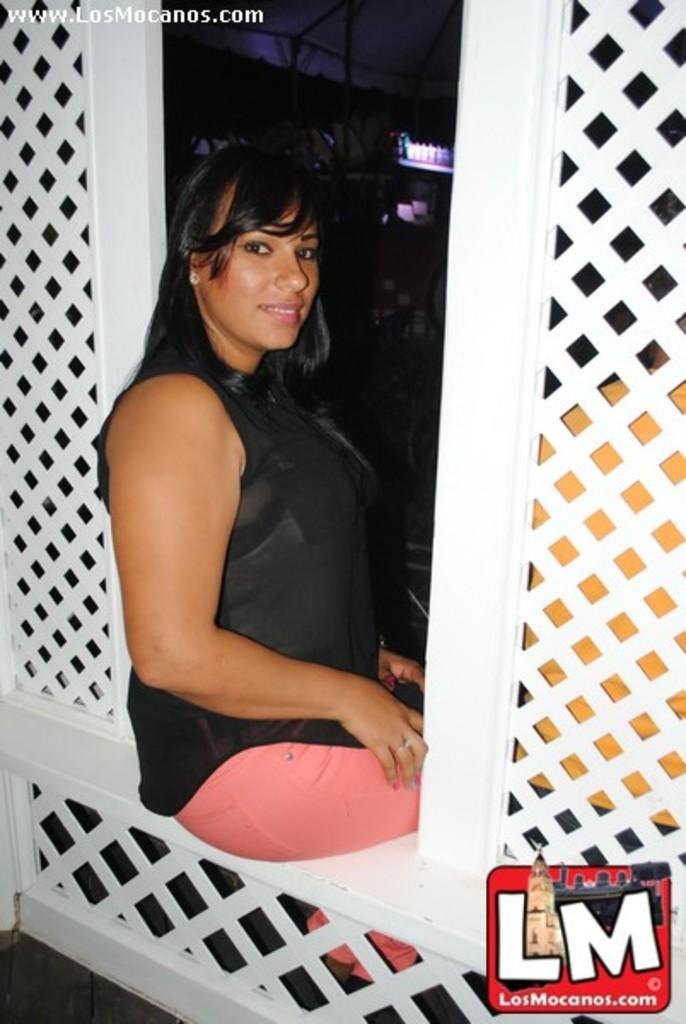What is the woman in the image doing? The woman is sitting on a fence in the image. Can you describe the person sitting behind the fence? There is a person sitting behind the fence on the right side. What can be seen in the background of the image? There are shelves in the background of the image. What is on the shelves? There are objects on the shelves. How many kittens are sitting on the queen's lap in the image? There is no queen or kittens present in the image. What type of donkey can be seen interacting with the objects on the shelves? There is no donkey present in the image; only the woman, the person, the fence, and the shelves with objects are visible. 